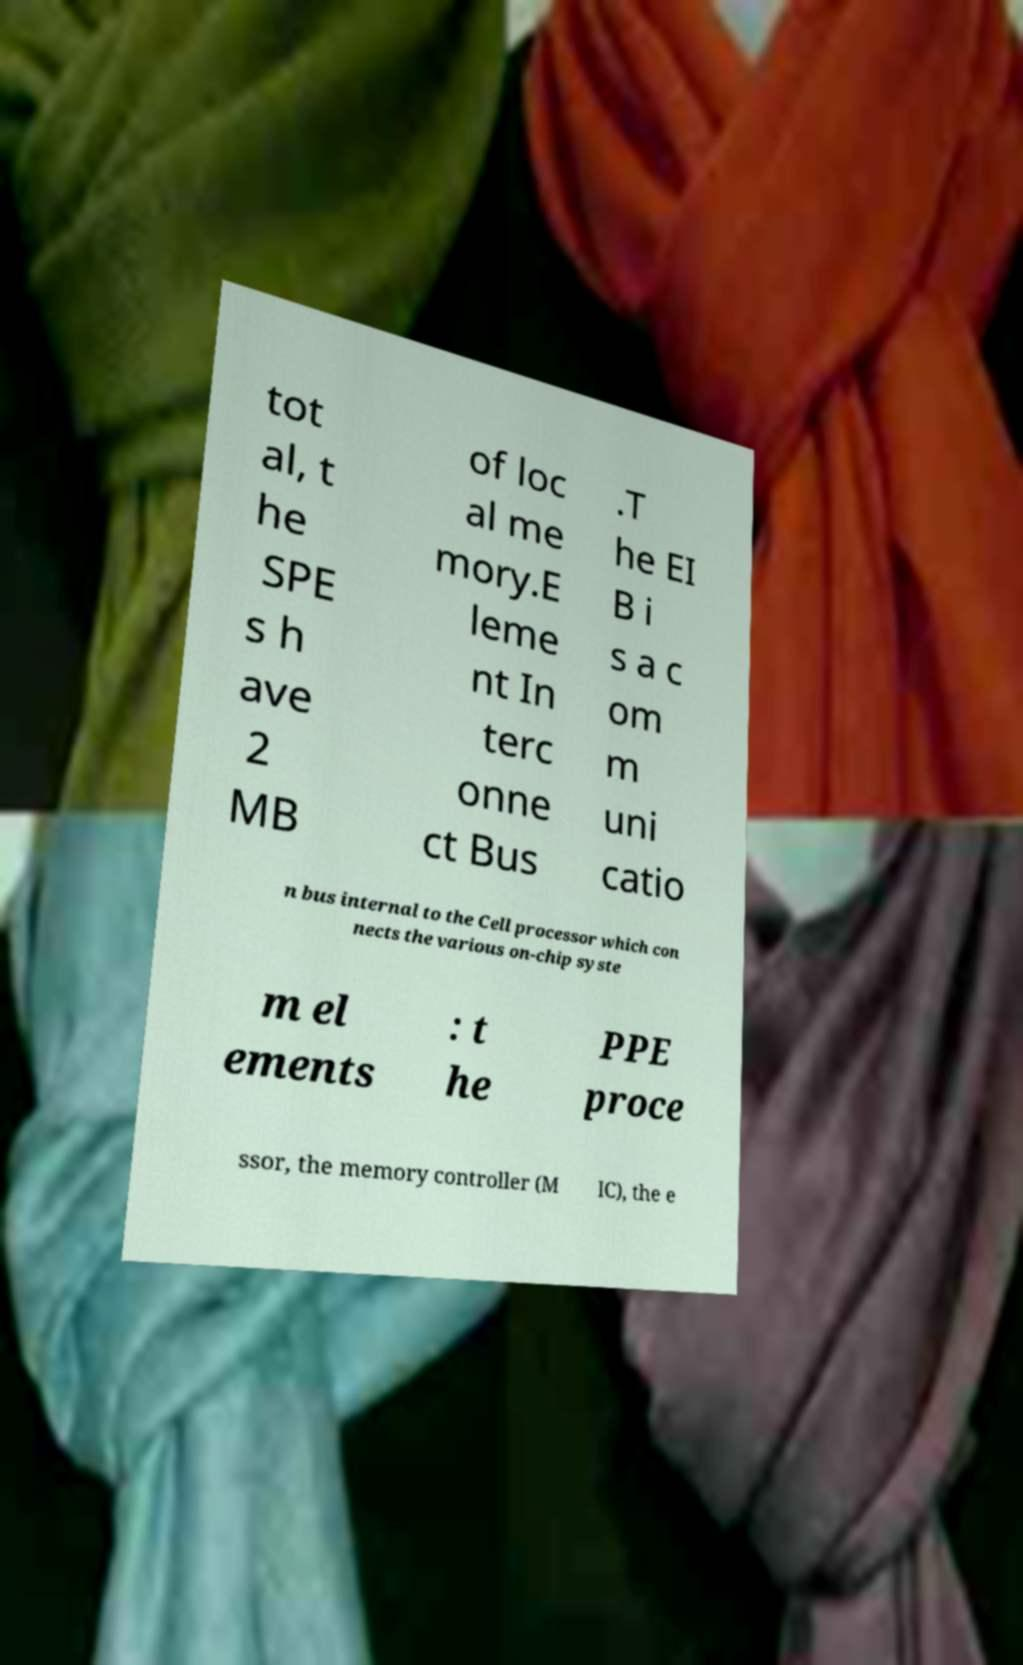There's text embedded in this image that I need extracted. Can you transcribe it verbatim? tot al, t he SPE s h ave 2 MB of loc al me mory.E leme nt In terc onne ct Bus .T he EI B i s a c om m uni catio n bus internal to the Cell processor which con nects the various on-chip syste m el ements : t he PPE proce ssor, the memory controller (M IC), the e 